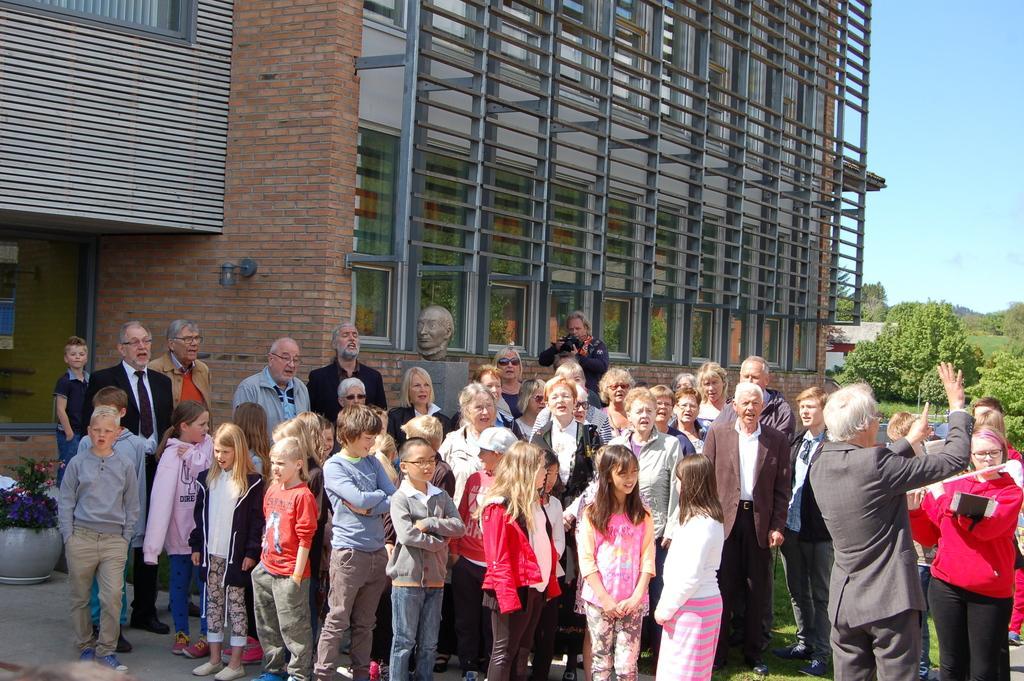In one or two sentences, can you explain what this image depicts? In this image in the front there are group of persons standing and smiling. In the background there is a building and there are trees and there's grass on the ground. 